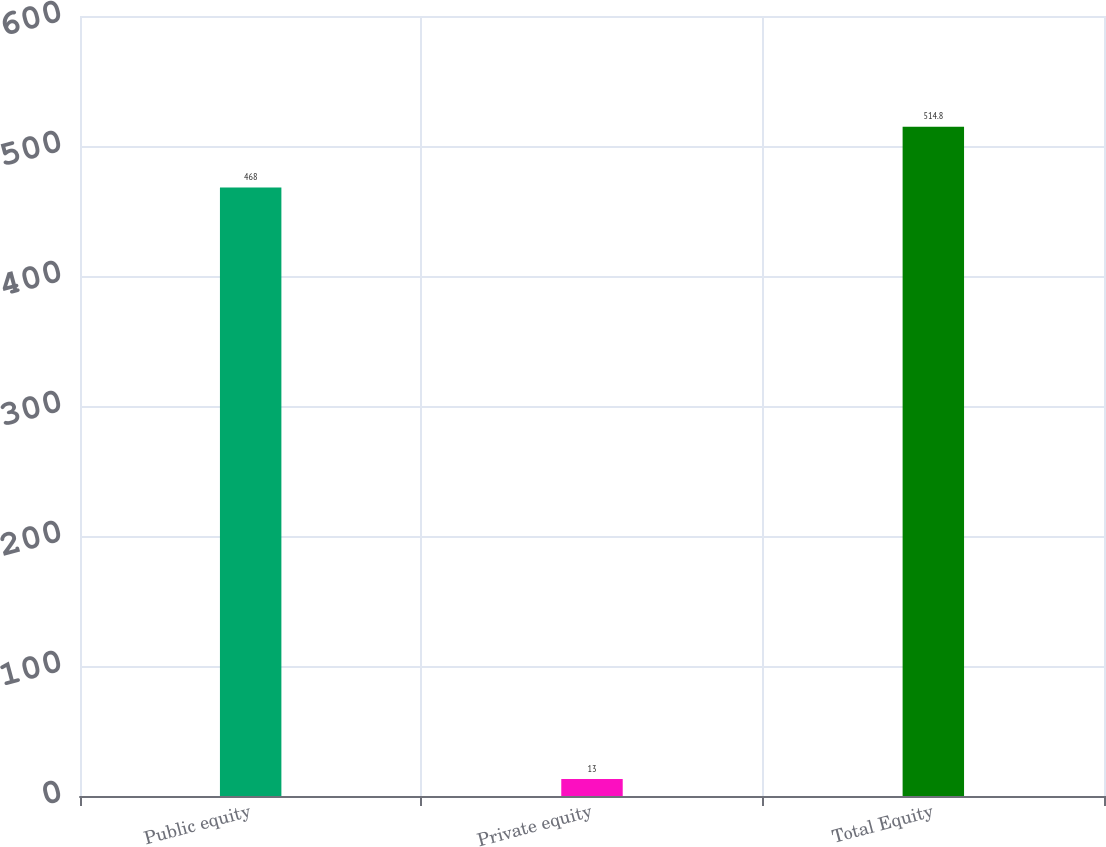Convert chart to OTSL. <chart><loc_0><loc_0><loc_500><loc_500><bar_chart><fcel>Public equity<fcel>Private equity<fcel>Total Equity<nl><fcel>468<fcel>13<fcel>514.8<nl></chart> 